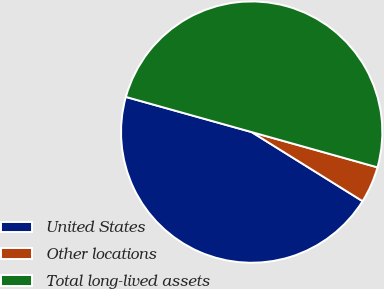<chart> <loc_0><loc_0><loc_500><loc_500><pie_chart><fcel>United States<fcel>Other locations<fcel>Total long-lived assets<nl><fcel>45.47%<fcel>4.52%<fcel>50.01%<nl></chart> 